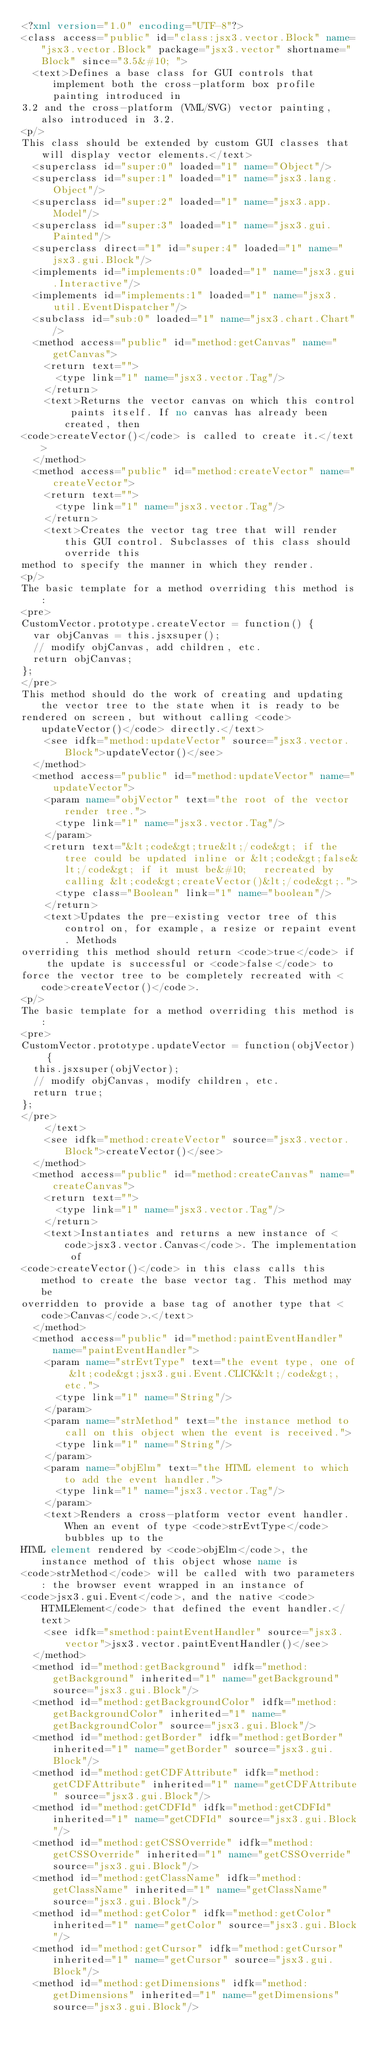Convert code to text. <code><loc_0><loc_0><loc_500><loc_500><_XML_><?xml version="1.0" encoding="UTF-8"?>
<class access="public" id="class:jsx3.vector.Block" name="jsx3.vector.Block" package="jsx3.vector" shortname="Block" since="3.5&#10; ">
  <text>Defines a base class for GUI controls that implement both the cross-platform box profile painting introduced in
3.2 and the cross-platform (VML/SVG) vector painting, also introduced in 3.2.
<p/>
This class should be extended by custom GUI classes that will display vector elements.</text>
  <superclass id="super:0" loaded="1" name="Object"/>
  <superclass id="super:1" loaded="1" name="jsx3.lang.Object"/>
  <superclass id="super:2" loaded="1" name="jsx3.app.Model"/>
  <superclass id="super:3" loaded="1" name="jsx3.gui.Painted"/>
  <superclass direct="1" id="super:4" loaded="1" name="jsx3.gui.Block"/>
  <implements id="implements:0" loaded="1" name="jsx3.gui.Interactive"/>
  <implements id="implements:1" loaded="1" name="jsx3.util.EventDispatcher"/>
  <subclass id="sub:0" loaded="1" name="jsx3.chart.Chart"/>
  <method access="public" id="method:getCanvas" name="getCanvas">
    <return text="">
      <type link="1" name="jsx3.vector.Tag"/>
    </return>
    <text>Returns the vector canvas on which this control paints itself. If no canvas has already been created, then
<code>createVector()</code> is called to create it.</text>
  </method>
  <method access="public" id="method:createVector" name="createVector">
    <return text="">
      <type link="1" name="jsx3.vector.Tag"/>
    </return>
    <text>Creates the vector tag tree that will render this GUI control. Subclasses of this class should override this
method to specify the manner in which they render.
<p/>
The basic template for a method overriding this method is:
<pre>
CustomVector.prototype.createVector = function() {
  var objCanvas = this.jsxsuper();
  // modify objCanvas, add children, etc.
  return objCanvas;
};
</pre>
This method should do the work of creating and updating the vector tree to the state when it is ready to be
rendered on screen, but without calling <code>updateVector()</code> directly.</text>
    <see idfk="method:updateVector" source="jsx3.vector.Block">updateVector()</see>
  </method>
  <method access="public" id="method:updateVector" name="updateVector">
    <param name="objVector" text="the root of the vector render tree.">
      <type link="1" name="jsx3.vector.Tag"/>
    </param>
    <return text="&lt;code&gt;true&lt;/code&gt; if the tree could be updated inline or &lt;code&gt;false&lt;/code&gt; if it must be&#10;   recreated by calling &lt;code&gt;createVector()&lt;/code&gt;.">
      <type class="Boolean" link="1" name="boolean"/>
    </return>
    <text>Updates the pre-existing vector tree of this control on, for example, a resize or repaint event. Methods
overriding this method should return <code>true</code> if the update is successful or <code>false</code> to
force the vector tree to be completely recreated with <code>createVector()</code>.
<p/>
The basic template for a method overriding this method is:
<pre>
CustomVector.prototype.updateVector = function(objVector) {
  this.jsxsuper(objVector);
  // modify objCanvas, modify children, etc.
  return true;
};
</pre>
    </text>
    <see idfk="method:createVector" source="jsx3.vector.Block">createVector()</see>
  </method>
  <method access="public" id="method:createCanvas" name="createCanvas">
    <return text="">
      <type link="1" name="jsx3.vector.Tag"/>
    </return>
    <text>Instantiates and returns a new instance of <code>jsx3.vector.Canvas</code>. The implementation of
<code>createVector()</code> in this class calls this method to create the base vector tag. This method may be
overridden to provide a base tag of another type that <code>Canvas</code>.</text>
  </method>
  <method access="public" id="method:paintEventHandler" name="paintEventHandler">
    <param name="strEvtType" text="the event type, one of &lt;code&gt;jsx3.gui.Event.CLICK&lt;/code&gt;, etc.">
      <type link="1" name="String"/>
    </param>
    <param name="strMethod" text="the instance method to call on this object when the event is received.">
      <type link="1" name="String"/>
    </param>
    <param name="objElm" text="the HTML element to which to add the event handler.">
      <type link="1" name="jsx3.vector.Tag"/>
    </param>
    <text>Renders a cross-platform vector event handler. When an event of type <code>strEvtType</code> bubbles up to the
HTML element rendered by <code>objElm</code>, the instance method of this object whose name is
<code>strMethod</code> will be called with two parameters: the browser event wrapped in an instance of
<code>jsx3.gui.Event</code>, and the native <code>HTMLElement</code> that defined the event handler.</text>
    <see idfk="smethod:paintEventHandler" source="jsx3.vector">jsx3.vector.paintEventHandler()</see>
  </method>
  <method id="method:getBackground" idfk="method:getBackground" inherited="1" name="getBackground" source="jsx3.gui.Block"/>
  <method id="method:getBackgroundColor" idfk="method:getBackgroundColor" inherited="1" name="getBackgroundColor" source="jsx3.gui.Block"/>
  <method id="method:getBorder" idfk="method:getBorder" inherited="1" name="getBorder" source="jsx3.gui.Block"/>
  <method id="method:getCDFAttribute" idfk="method:getCDFAttribute" inherited="1" name="getCDFAttribute" source="jsx3.gui.Block"/>
  <method id="method:getCDFId" idfk="method:getCDFId" inherited="1" name="getCDFId" source="jsx3.gui.Block"/>
  <method id="method:getCSSOverride" idfk="method:getCSSOverride" inherited="1" name="getCSSOverride" source="jsx3.gui.Block"/>
  <method id="method:getClassName" idfk="method:getClassName" inherited="1" name="getClassName" source="jsx3.gui.Block"/>
  <method id="method:getColor" idfk="method:getColor" inherited="1" name="getColor" source="jsx3.gui.Block"/>
  <method id="method:getCursor" idfk="method:getCursor" inherited="1" name="getCursor" source="jsx3.gui.Block"/>
  <method id="method:getDimensions" idfk="method:getDimensions" inherited="1" name="getDimensions" source="jsx3.gui.Block"/></code> 